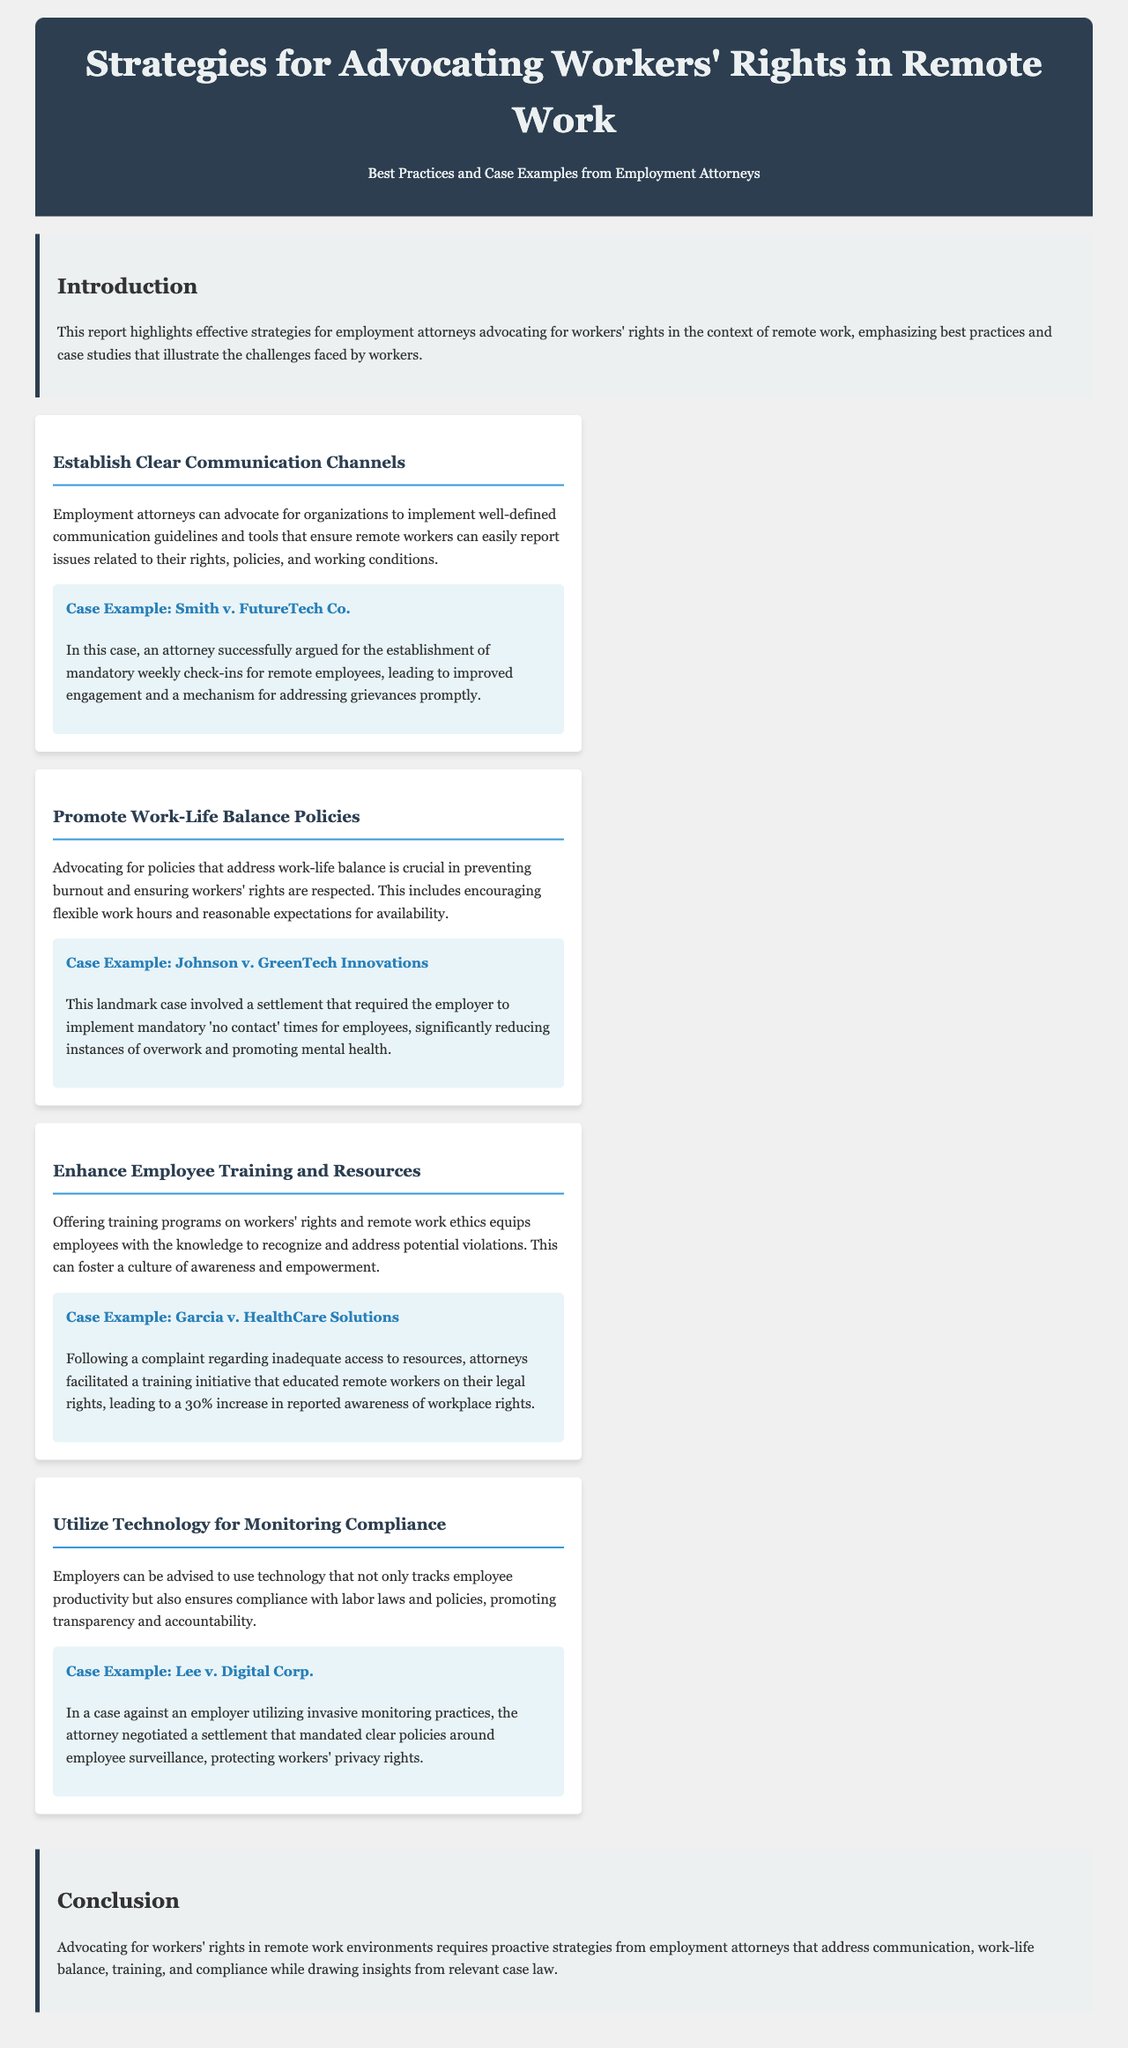What is the title of the report? The title of the report is found in the header section and provides a clear topic for the document.
Answer: Strategies for Advocating Workers' Rights in Remote Work What is the first strategy mentioned in the document? The first strategy is listed in the strategies section, highlighting a key approach for employment attorneys.
Answer: Establish Clear Communication Channels How many case examples are provided in the report? The report includes a total of four case examples, each illustrating a specific strategy.
Answer: Four What was required of FutureTech Co. in the Smith case? This information is specified within the case example to illustrate a successful outcome for workers' rights.
Answer: Mandatory weekly check-ins What issue did the Johnson case address regarding work policies? The case example explicitly identifies the problem that the settlement aimed to resolve, related to employee workload.
Answer: Mandatory 'no contact' times In which case was there a 30% increase in reported awareness of rights? This figure is directly mentioned in the context of employee training and resources, specifically detailing an outcome of a case.
Answer: Garcia v. HealthCare Solutions What is emphasized as crucial for remote workers in the report? The report highlights a specific aspect that is essential for maintaining the well-being of remote employees.
Answer: Work-life balance policies Which practice was negotiated in Lee v. Digital Corp.? This case example illustrates an important negotiation regarding employee rights in the workplace.
Answer: Clear policies around employee surveillance 